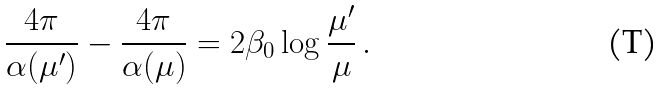<formula> <loc_0><loc_0><loc_500><loc_500>\frac { 4 \pi } { \alpha ( \mu ^ { \prime } ) } - \frac { 4 \pi } { \alpha ( \mu ) } = 2 \beta _ { 0 } \log \frac { \mu ^ { \prime } } { \mu } \, .</formula> 